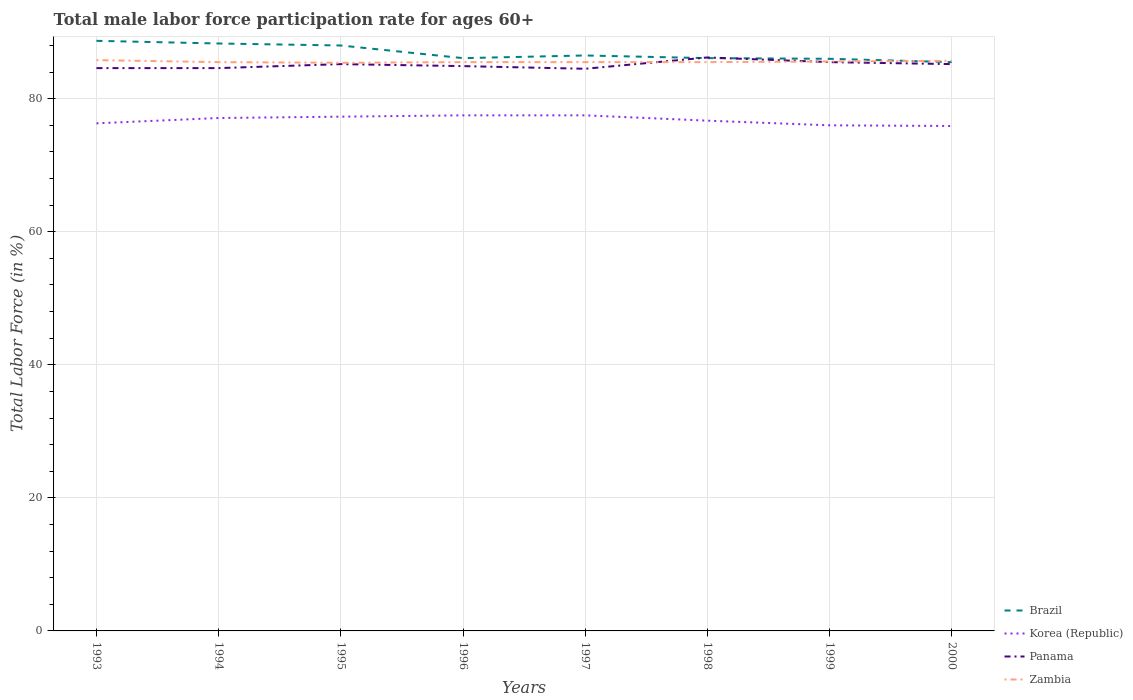How many different coloured lines are there?
Offer a very short reply. 4. Is the number of lines equal to the number of legend labels?
Offer a very short reply. Yes. Across all years, what is the maximum male labor force participation rate in Panama?
Offer a terse response. 84.5. What is the total male labor force participation rate in Panama in the graph?
Offer a terse response. 0.3. What is the difference between the highest and the second highest male labor force participation rate in Korea (Republic)?
Make the answer very short. 1.6. What is the difference between the highest and the lowest male labor force participation rate in Panama?
Give a very brief answer. 4. How many lines are there?
Provide a succinct answer. 4. What is the difference between two consecutive major ticks on the Y-axis?
Provide a succinct answer. 20. Does the graph contain any zero values?
Your answer should be compact. No. Where does the legend appear in the graph?
Provide a succinct answer. Bottom right. What is the title of the graph?
Your answer should be very brief. Total male labor force participation rate for ages 60+. Does "Hungary" appear as one of the legend labels in the graph?
Provide a succinct answer. No. What is the label or title of the X-axis?
Offer a very short reply. Years. What is the label or title of the Y-axis?
Make the answer very short. Total Labor Force (in %). What is the Total Labor Force (in %) of Brazil in 1993?
Ensure brevity in your answer.  88.7. What is the Total Labor Force (in %) in Korea (Republic) in 1993?
Give a very brief answer. 76.3. What is the Total Labor Force (in %) in Panama in 1993?
Offer a very short reply. 84.6. What is the Total Labor Force (in %) in Zambia in 1993?
Make the answer very short. 85.8. What is the Total Labor Force (in %) in Brazil in 1994?
Offer a very short reply. 88.3. What is the Total Labor Force (in %) in Korea (Republic) in 1994?
Your answer should be very brief. 77.1. What is the Total Labor Force (in %) of Panama in 1994?
Offer a terse response. 84.6. What is the Total Labor Force (in %) in Zambia in 1994?
Provide a succinct answer. 85.5. What is the Total Labor Force (in %) in Korea (Republic) in 1995?
Your answer should be very brief. 77.3. What is the Total Labor Force (in %) of Panama in 1995?
Keep it short and to the point. 85.2. What is the Total Labor Force (in %) in Zambia in 1995?
Provide a short and direct response. 85.4. What is the Total Labor Force (in %) in Brazil in 1996?
Offer a very short reply. 86.1. What is the Total Labor Force (in %) of Korea (Republic) in 1996?
Offer a terse response. 77.5. What is the Total Labor Force (in %) of Panama in 1996?
Provide a short and direct response. 84.9. What is the Total Labor Force (in %) in Zambia in 1996?
Your answer should be very brief. 85.5. What is the Total Labor Force (in %) in Brazil in 1997?
Your answer should be compact. 86.5. What is the Total Labor Force (in %) in Korea (Republic) in 1997?
Give a very brief answer. 77.5. What is the Total Labor Force (in %) in Panama in 1997?
Offer a very short reply. 84.5. What is the Total Labor Force (in %) of Zambia in 1997?
Your answer should be compact. 85.5. What is the Total Labor Force (in %) of Brazil in 1998?
Offer a very short reply. 86.1. What is the Total Labor Force (in %) in Korea (Republic) in 1998?
Offer a terse response. 76.7. What is the Total Labor Force (in %) in Panama in 1998?
Your answer should be compact. 86.2. What is the Total Labor Force (in %) of Zambia in 1998?
Offer a terse response. 85.5. What is the Total Labor Force (in %) in Brazil in 1999?
Your response must be concise. 86. What is the Total Labor Force (in %) of Panama in 1999?
Keep it short and to the point. 85.5. What is the Total Labor Force (in %) in Zambia in 1999?
Make the answer very short. 85.6. What is the Total Labor Force (in %) in Brazil in 2000?
Your answer should be compact. 85.5. What is the Total Labor Force (in %) of Korea (Republic) in 2000?
Keep it short and to the point. 75.9. What is the Total Labor Force (in %) in Panama in 2000?
Give a very brief answer. 85.2. What is the Total Labor Force (in %) of Zambia in 2000?
Provide a short and direct response. 85.7. Across all years, what is the maximum Total Labor Force (in %) in Brazil?
Make the answer very short. 88.7. Across all years, what is the maximum Total Labor Force (in %) of Korea (Republic)?
Your answer should be compact. 77.5. Across all years, what is the maximum Total Labor Force (in %) in Panama?
Offer a terse response. 86.2. Across all years, what is the maximum Total Labor Force (in %) in Zambia?
Provide a succinct answer. 85.8. Across all years, what is the minimum Total Labor Force (in %) in Brazil?
Give a very brief answer. 85.5. Across all years, what is the minimum Total Labor Force (in %) of Korea (Republic)?
Make the answer very short. 75.9. Across all years, what is the minimum Total Labor Force (in %) of Panama?
Your response must be concise. 84.5. Across all years, what is the minimum Total Labor Force (in %) in Zambia?
Provide a short and direct response. 85.4. What is the total Total Labor Force (in %) of Brazil in the graph?
Keep it short and to the point. 695.2. What is the total Total Labor Force (in %) of Korea (Republic) in the graph?
Give a very brief answer. 614.3. What is the total Total Labor Force (in %) in Panama in the graph?
Give a very brief answer. 680.7. What is the total Total Labor Force (in %) in Zambia in the graph?
Give a very brief answer. 684.5. What is the difference between the Total Labor Force (in %) of Brazil in 1993 and that in 1994?
Keep it short and to the point. 0.4. What is the difference between the Total Labor Force (in %) of Korea (Republic) in 1993 and that in 1994?
Your answer should be very brief. -0.8. What is the difference between the Total Labor Force (in %) of Panama in 1993 and that in 1994?
Your answer should be compact. 0. What is the difference between the Total Labor Force (in %) of Zambia in 1993 and that in 1994?
Keep it short and to the point. 0.3. What is the difference between the Total Labor Force (in %) in Brazil in 1993 and that in 1995?
Your response must be concise. 0.7. What is the difference between the Total Labor Force (in %) of Korea (Republic) in 1993 and that in 1995?
Ensure brevity in your answer.  -1. What is the difference between the Total Labor Force (in %) of Panama in 1993 and that in 1995?
Offer a terse response. -0.6. What is the difference between the Total Labor Force (in %) in Brazil in 1993 and that in 1996?
Your response must be concise. 2.6. What is the difference between the Total Labor Force (in %) in Korea (Republic) in 1993 and that in 1996?
Keep it short and to the point. -1.2. What is the difference between the Total Labor Force (in %) in Zambia in 1993 and that in 1996?
Offer a very short reply. 0.3. What is the difference between the Total Labor Force (in %) of Brazil in 1993 and that in 1997?
Provide a succinct answer. 2.2. What is the difference between the Total Labor Force (in %) of Korea (Republic) in 1993 and that in 1997?
Ensure brevity in your answer.  -1.2. What is the difference between the Total Labor Force (in %) of Panama in 1993 and that in 1998?
Ensure brevity in your answer.  -1.6. What is the difference between the Total Labor Force (in %) of Brazil in 1993 and that in 1999?
Keep it short and to the point. 2.7. What is the difference between the Total Labor Force (in %) of Korea (Republic) in 1993 and that in 1999?
Offer a terse response. 0.3. What is the difference between the Total Labor Force (in %) in Panama in 1993 and that in 1999?
Keep it short and to the point. -0.9. What is the difference between the Total Labor Force (in %) of Zambia in 1993 and that in 1999?
Provide a short and direct response. 0.2. What is the difference between the Total Labor Force (in %) of Korea (Republic) in 1993 and that in 2000?
Provide a succinct answer. 0.4. What is the difference between the Total Labor Force (in %) in Panama in 1993 and that in 2000?
Offer a very short reply. -0.6. What is the difference between the Total Labor Force (in %) of Zambia in 1993 and that in 2000?
Offer a very short reply. 0.1. What is the difference between the Total Labor Force (in %) of Brazil in 1994 and that in 1995?
Give a very brief answer. 0.3. What is the difference between the Total Labor Force (in %) of Panama in 1994 and that in 1995?
Provide a succinct answer. -0.6. What is the difference between the Total Labor Force (in %) in Brazil in 1994 and that in 1996?
Provide a short and direct response. 2.2. What is the difference between the Total Labor Force (in %) of Zambia in 1994 and that in 1996?
Offer a terse response. 0. What is the difference between the Total Labor Force (in %) in Brazil in 1994 and that in 1997?
Give a very brief answer. 1.8. What is the difference between the Total Labor Force (in %) in Panama in 1994 and that in 1997?
Offer a very short reply. 0.1. What is the difference between the Total Labor Force (in %) of Zambia in 1994 and that in 1997?
Keep it short and to the point. 0. What is the difference between the Total Labor Force (in %) in Brazil in 1994 and that in 1998?
Ensure brevity in your answer.  2.2. What is the difference between the Total Labor Force (in %) of Korea (Republic) in 1994 and that in 1998?
Make the answer very short. 0.4. What is the difference between the Total Labor Force (in %) in Brazil in 1994 and that in 1999?
Make the answer very short. 2.3. What is the difference between the Total Labor Force (in %) of Korea (Republic) in 1994 and that in 1999?
Keep it short and to the point. 1.1. What is the difference between the Total Labor Force (in %) of Zambia in 1994 and that in 1999?
Provide a short and direct response. -0.1. What is the difference between the Total Labor Force (in %) in Brazil in 1994 and that in 2000?
Give a very brief answer. 2.8. What is the difference between the Total Labor Force (in %) of Panama in 1994 and that in 2000?
Your answer should be compact. -0.6. What is the difference between the Total Labor Force (in %) of Panama in 1995 and that in 1996?
Give a very brief answer. 0.3. What is the difference between the Total Labor Force (in %) of Zambia in 1995 and that in 1996?
Keep it short and to the point. -0.1. What is the difference between the Total Labor Force (in %) in Brazil in 1995 and that in 1997?
Keep it short and to the point. 1.5. What is the difference between the Total Labor Force (in %) of Korea (Republic) in 1995 and that in 1997?
Make the answer very short. -0.2. What is the difference between the Total Labor Force (in %) of Panama in 1995 and that in 1997?
Ensure brevity in your answer.  0.7. What is the difference between the Total Labor Force (in %) of Korea (Republic) in 1995 and that in 1998?
Your answer should be compact. 0.6. What is the difference between the Total Labor Force (in %) in Panama in 1995 and that in 1998?
Make the answer very short. -1. What is the difference between the Total Labor Force (in %) in Zambia in 1995 and that in 1998?
Provide a short and direct response. -0.1. What is the difference between the Total Labor Force (in %) in Brazil in 1995 and that in 1999?
Your answer should be compact. 2. What is the difference between the Total Labor Force (in %) in Korea (Republic) in 1995 and that in 1999?
Keep it short and to the point. 1.3. What is the difference between the Total Labor Force (in %) of Brazil in 1995 and that in 2000?
Your answer should be compact. 2.5. What is the difference between the Total Labor Force (in %) in Korea (Republic) in 1995 and that in 2000?
Your answer should be compact. 1.4. What is the difference between the Total Labor Force (in %) in Panama in 1995 and that in 2000?
Your answer should be compact. 0. What is the difference between the Total Labor Force (in %) of Brazil in 1996 and that in 1997?
Give a very brief answer. -0.4. What is the difference between the Total Labor Force (in %) of Zambia in 1996 and that in 1997?
Offer a terse response. 0. What is the difference between the Total Labor Force (in %) in Brazil in 1996 and that in 1998?
Provide a succinct answer. 0. What is the difference between the Total Labor Force (in %) of Zambia in 1996 and that in 1998?
Offer a terse response. 0. What is the difference between the Total Labor Force (in %) of Brazil in 1996 and that in 1999?
Offer a very short reply. 0.1. What is the difference between the Total Labor Force (in %) in Brazil in 1996 and that in 2000?
Offer a terse response. 0.6. What is the difference between the Total Labor Force (in %) of Korea (Republic) in 1996 and that in 2000?
Ensure brevity in your answer.  1.6. What is the difference between the Total Labor Force (in %) of Zambia in 1996 and that in 2000?
Offer a terse response. -0.2. What is the difference between the Total Labor Force (in %) of Brazil in 1997 and that in 1998?
Your response must be concise. 0.4. What is the difference between the Total Labor Force (in %) of Zambia in 1997 and that in 1998?
Ensure brevity in your answer.  0. What is the difference between the Total Labor Force (in %) in Brazil in 1997 and that in 1999?
Give a very brief answer. 0.5. What is the difference between the Total Labor Force (in %) of Korea (Republic) in 1997 and that in 1999?
Offer a very short reply. 1.5. What is the difference between the Total Labor Force (in %) of Korea (Republic) in 1997 and that in 2000?
Keep it short and to the point. 1.6. What is the difference between the Total Labor Force (in %) in Zambia in 1997 and that in 2000?
Ensure brevity in your answer.  -0.2. What is the difference between the Total Labor Force (in %) in Zambia in 1998 and that in 1999?
Provide a succinct answer. -0.1. What is the difference between the Total Labor Force (in %) in Brazil in 1998 and that in 2000?
Your answer should be compact. 0.6. What is the difference between the Total Labor Force (in %) in Panama in 1998 and that in 2000?
Offer a very short reply. 1. What is the difference between the Total Labor Force (in %) in Zambia in 1998 and that in 2000?
Your answer should be very brief. -0.2. What is the difference between the Total Labor Force (in %) of Brazil in 1999 and that in 2000?
Make the answer very short. 0.5. What is the difference between the Total Labor Force (in %) of Korea (Republic) in 1999 and that in 2000?
Offer a terse response. 0.1. What is the difference between the Total Labor Force (in %) of Panama in 1999 and that in 2000?
Give a very brief answer. 0.3. What is the difference between the Total Labor Force (in %) of Zambia in 1999 and that in 2000?
Offer a terse response. -0.1. What is the difference between the Total Labor Force (in %) in Brazil in 1993 and the Total Labor Force (in %) in Korea (Republic) in 1994?
Keep it short and to the point. 11.6. What is the difference between the Total Labor Force (in %) in Brazil in 1993 and the Total Labor Force (in %) in Zambia in 1994?
Give a very brief answer. 3.2. What is the difference between the Total Labor Force (in %) in Brazil in 1993 and the Total Labor Force (in %) in Panama in 1995?
Offer a very short reply. 3.5. What is the difference between the Total Labor Force (in %) in Brazil in 1993 and the Total Labor Force (in %) in Korea (Republic) in 1996?
Your answer should be very brief. 11.2. What is the difference between the Total Labor Force (in %) in Brazil in 1993 and the Total Labor Force (in %) in Zambia in 1996?
Provide a short and direct response. 3.2. What is the difference between the Total Labor Force (in %) in Brazil in 1993 and the Total Labor Force (in %) in Korea (Republic) in 1997?
Provide a succinct answer. 11.2. What is the difference between the Total Labor Force (in %) of Brazil in 1993 and the Total Labor Force (in %) of Zambia in 1997?
Offer a terse response. 3.2. What is the difference between the Total Labor Force (in %) of Korea (Republic) in 1993 and the Total Labor Force (in %) of Panama in 1997?
Provide a succinct answer. -8.2. What is the difference between the Total Labor Force (in %) of Korea (Republic) in 1993 and the Total Labor Force (in %) of Zambia in 1997?
Your answer should be very brief. -9.2. What is the difference between the Total Labor Force (in %) in Panama in 1993 and the Total Labor Force (in %) in Zambia in 1997?
Your response must be concise. -0.9. What is the difference between the Total Labor Force (in %) in Korea (Republic) in 1993 and the Total Labor Force (in %) in Panama in 1998?
Your answer should be very brief. -9.9. What is the difference between the Total Labor Force (in %) in Brazil in 1993 and the Total Labor Force (in %) in Zambia in 1999?
Keep it short and to the point. 3.1. What is the difference between the Total Labor Force (in %) of Korea (Republic) in 1993 and the Total Labor Force (in %) of Panama in 1999?
Keep it short and to the point. -9.2. What is the difference between the Total Labor Force (in %) in Brazil in 1993 and the Total Labor Force (in %) in Panama in 2000?
Offer a terse response. 3.5. What is the difference between the Total Labor Force (in %) of Brazil in 1993 and the Total Labor Force (in %) of Zambia in 2000?
Provide a short and direct response. 3. What is the difference between the Total Labor Force (in %) in Korea (Republic) in 1993 and the Total Labor Force (in %) in Panama in 2000?
Offer a terse response. -8.9. What is the difference between the Total Labor Force (in %) in Panama in 1993 and the Total Labor Force (in %) in Zambia in 2000?
Your response must be concise. -1.1. What is the difference between the Total Labor Force (in %) of Brazil in 1994 and the Total Labor Force (in %) of Korea (Republic) in 1995?
Provide a short and direct response. 11. What is the difference between the Total Labor Force (in %) of Brazil in 1994 and the Total Labor Force (in %) of Panama in 1995?
Your answer should be compact. 3.1. What is the difference between the Total Labor Force (in %) of Korea (Republic) in 1994 and the Total Labor Force (in %) of Panama in 1995?
Keep it short and to the point. -8.1. What is the difference between the Total Labor Force (in %) of Korea (Republic) in 1994 and the Total Labor Force (in %) of Zambia in 1995?
Keep it short and to the point. -8.3. What is the difference between the Total Labor Force (in %) in Brazil in 1994 and the Total Labor Force (in %) in Korea (Republic) in 1996?
Your answer should be very brief. 10.8. What is the difference between the Total Labor Force (in %) in Korea (Republic) in 1994 and the Total Labor Force (in %) in Panama in 1996?
Your response must be concise. -7.8. What is the difference between the Total Labor Force (in %) of Brazil in 1994 and the Total Labor Force (in %) of Panama in 1997?
Offer a very short reply. 3.8. What is the difference between the Total Labor Force (in %) in Korea (Republic) in 1994 and the Total Labor Force (in %) in Zambia in 1997?
Offer a terse response. -8.4. What is the difference between the Total Labor Force (in %) of Brazil in 1994 and the Total Labor Force (in %) of Korea (Republic) in 1998?
Ensure brevity in your answer.  11.6. What is the difference between the Total Labor Force (in %) in Brazil in 1994 and the Total Labor Force (in %) in Panama in 1998?
Offer a very short reply. 2.1. What is the difference between the Total Labor Force (in %) of Korea (Republic) in 1994 and the Total Labor Force (in %) of Zambia in 1998?
Ensure brevity in your answer.  -8.4. What is the difference between the Total Labor Force (in %) of Brazil in 1994 and the Total Labor Force (in %) of Zambia in 1999?
Keep it short and to the point. 2.7. What is the difference between the Total Labor Force (in %) in Panama in 1994 and the Total Labor Force (in %) in Zambia in 1999?
Your answer should be very brief. -1. What is the difference between the Total Labor Force (in %) of Brazil in 1994 and the Total Labor Force (in %) of Korea (Republic) in 2000?
Offer a very short reply. 12.4. What is the difference between the Total Labor Force (in %) of Brazil in 1994 and the Total Labor Force (in %) of Panama in 2000?
Ensure brevity in your answer.  3.1. What is the difference between the Total Labor Force (in %) in Korea (Republic) in 1995 and the Total Labor Force (in %) in Panama in 1996?
Give a very brief answer. -7.6. What is the difference between the Total Labor Force (in %) in Panama in 1995 and the Total Labor Force (in %) in Zambia in 1996?
Keep it short and to the point. -0.3. What is the difference between the Total Labor Force (in %) in Brazil in 1995 and the Total Labor Force (in %) in Korea (Republic) in 1997?
Your answer should be compact. 10.5. What is the difference between the Total Labor Force (in %) of Brazil in 1995 and the Total Labor Force (in %) of Panama in 1997?
Keep it short and to the point. 3.5. What is the difference between the Total Labor Force (in %) of Brazil in 1995 and the Total Labor Force (in %) of Zambia in 1997?
Provide a succinct answer. 2.5. What is the difference between the Total Labor Force (in %) of Korea (Republic) in 1995 and the Total Labor Force (in %) of Panama in 1997?
Provide a short and direct response. -7.2. What is the difference between the Total Labor Force (in %) in Brazil in 1995 and the Total Labor Force (in %) in Korea (Republic) in 1998?
Provide a succinct answer. 11.3. What is the difference between the Total Labor Force (in %) of Brazil in 1995 and the Total Labor Force (in %) of Zambia in 1998?
Ensure brevity in your answer.  2.5. What is the difference between the Total Labor Force (in %) in Korea (Republic) in 1995 and the Total Labor Force (in %) in Panama in 1998?
Provide a succinct answer. -8.9. What is the difference between the Total Labor Force (in %) of Panama in 1995 and the Total Labor Force (in %) of Zambia in 1998?
Your answer should be compact. -0.3. What is the difference between the Total Labor Force (in %) of Brazil in 1995 and the Total Labor Force (in %) of Korea (Republic) in 1999?
Provide a short and direct response. 12. What is the difference between the Total Labor Force (in %) in Brazil in 1995 and the Total Labor Force (in %) in Panama in 1999?
Provide a succinct answer. 2.5. What is the difference between the Total Labor Force (in %) in Brazil in 1995 and the Total Labor Force (in %) in Zambia in 1999?
Provide a short and direct response. 2.4. What is the difference between the Total Labor Force (in %) in Panama in 1995 and the Total Labor Force (in %) in Zambia in 1999?
Your answer should be compact. -0.4. What is the difference between the Total Labor Force (in %) in Brazil in 1995 and the Total Labor Force (in %) in Korea (Republic) in 2000?
Offer a very short reply. 12.1. What is the difference between the Total Labor Force (in %) of Korea (Republic) in 1995 and the Total Labor Force (in %) of Zambia in 2000?
Offer a very short reply. -8.4. What is the difference between the Total Labor Force (in %) in Panama in 1995 and the Total Labor Force (in %) in Zambia in 2000?
Your answer should be compact. -0.5. What is the difference between the Total Labor Force (in %) of Brazil in 1996 and the Total Labor Force (in %) of Panama in 1997?
Your answer should be compact. 1.6. What is the difference between the Total Labor Force (in %) in Brazil in 1996 and the Total Labor Force (in %) in Zambia in 1997?
Provide a succinct answer. 0.6. What is the difference between the Total Labor Force (in %) of Korea (Republic) in 1996 and the Total Labor Force (in %) of Panama in 1997?
Give a very brief answer. -7. What is the difference between the Total Labor Force (in %) of Korea (Republic) in 1996 and the Total Labor Force (in %) of Zambia in 1997?
Make the answer very short. -8. What is the difference between the Total Labor Force (in %) in Panama in 1996 and the Total Labor Force (in %) in Zambia in 1997?
Your response must be concise. -0.6. What is the difference between the Total Labor Force (in %) in Korea (Republic) in 1996 and the Total Labor Force (in %) in Zambia in 1998?
Your answer should be compact. -8. What is the difference between the Total Labor Force (in %) in Panama in 1996 and the Total Labor Force (in %) in Zambia in 1998?
Make the answer very short. -0.6. What is the difference between the Total Labor Force (in %) in Brazil in 1996 and the Total Labor Force (in %) in Korea (Republic) in 1999?
Your answer should be very brief. 10.1. What is the difference between the Total Labor Force (in %) of Brazil in 1996 and the Total Labor Force (in %) of Zambia in 1999?
Provide a short and direct response. 0.5. What is the difference between the Total Labor Force (in %) in Brazil in 1996 and the Total Labor Force (in %) in Zambia in 2000?
Give a very brief answer. 0.4. What is the difference between the Total Labor Force (in %) in Brazil in 1997 and the Total Labor Force (in %) in Korea (Republic) in 1998?
Your answer should be compact. 9.8. What is the difference between the Total Labor Force (in %) of Brazil in 1997 and the Total Labor Force (in %) of Panama in 1998?
Provide a short and direct response. 0.3. What is the difference between the Total Labor Force (in %) of Korea (Republic) in 1997 and the Total Labor Force (in %) of Zambia in 1998?
Your response must be concise. -8. What is the difference between the Total Labor Force (in %) of Panama in 1997 and the Total Labor Force (in %) of Zambia in 1998?
Keep it short and to the point. -1. What is the difference between the Total Labor Force (in %) in Brazil in 1997 and the Total Labor Force (in %) in Zambia in 1999?
Give a very brief answer. 0.9. What is the difference between the Total Labor Force (in %) in Brazil in 1997 and the Total Labor Force (in %) in Korea (Republic) in 2000?
Provide a short and direct response. 10.6. What is the difference between the Total Labor Force (in %) in Brazil in 1997 and the Total Labor Force (in %) in Panama in 2000?
Make the answer very short. 1.3. What is the difference between the Total Labor Force (in %) in Brazil in 1997 and the Total Labor Force (in %) in Zambia in 2000?
Ensure brevity in your answer.  0.8. What is the difference between the Total Labor Force (in %) of Brazil in 1998 and the Total Labor Force (in %) of Zambia in 1999?
Provide a short and direct response. 0.5. What is the difference between the Total Labor Force (in %) of Korea (Republic) in 1998 and the Total Labor Force (in %) of Panama in 1999?
Your answer should be very brief. -8.8. What is the difference between the Total Labor Force (in %) in Korea (Republic) in 1998 and the Total Labor Force (in %) in Zambia in 1999?
Keep it short and to the point. -8.9. What is the difference between the Total Labor Force (in %) of Korea (Republic) in 1998 and the Total Labor Force (in %) of Zambia in 2000?
Offer a terse response. -9. What is the difference between the Total Labor Force (in %) of Panama in 1998 and the Total Labor Force (in %) of Zambia in 2000?
Offer a terse response. 0.5. What is the difference between the Total Labor Force (in %) of Brazil in 1999 and the Total Labor Force (in %) of Zambia in 2000?
Offer a very short reply. 0.3. What is the difference between the Total Labor Force (in %) of Korea (Republic) in 1999 and the Total Labor Force (in %) of Panama in 2000?
Make the answer very short. -9.2. What is the difference between the Total Labor Force (in %) of Panama in 1999 and the Total Labor Force (in %) of Zambia in 2000?
Provide a short and direct response. -0.2. What is the average Total Labor Force (in %) in Brazil per year?
Your answer should be very brief. 86.9. What is the average Total Labor Force (in %) in Korea (Republic) per year?
Keep it short and to the point. 76.79. What is the average Total Labor Force (in %) of Panama per year?
Keep it short and to the point. 85.09. What is the average Total Labor Force (in %) of Zambia per year?
Ensure brevity in your answer.  85.56. In the year 1993, what is the difference between the Total Labor Force (in %) of Brazil and Total Labor Force (in %) of Korea (Republic)?
Provide a succinct answer. 12.4. In the year 1993, what is the difference between the Total Labor Force (in %) of Brazil and Total Labor Force (in %) of Panama?
Provide a succinct answer. 4.1. In the year 1993, what is the difference between the Total Labor Force (in %) in Brazil and Total Labor Force (in %) in Zambia?
Offer a very short reply. 2.9. In the year 1993, what is the difference between the Total Labor Force (in %) in Korea (Republic) and Total Labor Force (in %) in Panama?
Your answer should be compact. -8.3. In the year 1993, what is the difference between the Total Labor Force (in %) in Panama and Total Labor Force (in %) in Zambia?
Give a very brief answer. -1.2. In the year 1994, what is the difference between the Total Labor Force (in %) in Brazil and Total Labor Force (in %) in Korea (Republic)?
Offer a very short reply. 11.2. In the year 1994, what is the difference between the Total Labor Force (in %) of Brazil and Total Labor Force (in %) of Panama?
Keep it short and to the point. 3.7. In the year 1994, what is the difference between the Total Labor Force (in %) of Brazil and Total Labor Force (in %) of Zambia?
Your answer should be compact. 2.8. In the year 1994, what is the difference between the Total Labor Force (in %) in Korea (Republic) and Total Labor Force (in %) in Panama?
Your answer should be compact. -7.5. In the year 1995, what is the difference between the Total Labor Force (in %) of Brazil and Total Labor Force (in %) of Panama?
Offer a terse response. 2.8. In the year 1995, what is the difference between the Total Labor Force (in %) of Korea (Republic) and Total Labor Force (in %) of Panama?
Ensure brevity in your answer.  -7.9. In the year 1995, what is the difference between the Total Labor Force (in %) of Korea (Republic) and Total Labor Force (in %) of Zambia?
Keep it short and to the point. -8.1. In the year 1996, what is the difference between the Total Labor Force (in %) in Brazil and Total Labor Force (in %) in Zambia?
Give a very brief answer. 0.6. In the year 1996, what is the difference between the Total Labor Force (in %) of Korea (Republic) and Total Labor Force (in %) of Panama?
Make the answer very short. -7.4. In the year 1997, what is the difference between the Total Labor Force (in %) of Brazil and Total Labor Force (in %) of Panama?
Keep it short and to the point. 2. In the year 1997, what is the difference between the Total Labor Force (in %) of Brazil and Total Labor Force (in %) of Zambia?
Give a very brief answer. 1. In the year 1997, what is the difference between the Total Labor Force (in %) of Korea (Republic) and Total Labor Force (in %) of Panama?
Give a very brief answer. -7. In the year 1997, what is the difference between the Total Labor Force (in %) in Korea (Republic) and Total Labor Force (in %) in Zambia?
Your answer should be compact. -8. In the year 1998, what is the difference between the Total Labor Force (in %) of Brazil and Total Labor Force (in %) of Panama?
Make the answer very short. -0.1. In the year 1998, what is the difference between the Total Labor Force (in %) of Brazil and Total Labor Force (in %) of Zambia?
Provide a succinct answer. 0.6. In the year 1998, what is the difference between the Total Labor Force (in %) of Korea (Republic) and Total Labor Force (in %) of Panama?
Your response must be concise. -9.5. In the year 1998, what is the difference between the Total Labor Force (in %) in Panama and Total Labor Force (in %) in Zambia?
Give a very brief answer. 0.7. In the year 1999, what is the difference between the Total Labor Force (in %) in Korea (Republic) and Total Labor Force (in %) in Zambia?
Your response must be concise. -9.6. In the year 1999, what is the difference between the Total Labor Force (in %) in Panama and Total Labor Force (in %) in Zambia?
Offer a terse response. -0.1. In the year 2000, what is the difference between the Total Labor Force (in %) in Brazil and Total Labor Force (in %) in Korea (Republic)?
Give a very brief answer. 9.6. What is the ratio of the Total Labor Force (in %) of Brazil in 1993 to that in 1995?
Offer a very short reply. 1.01. What is the ratio of the Total Labor Force (in %) of Korea (Republic) in 1993 to that in 1995?
Offer a very short reply. 0.99. What is the ratio of the Total Labor Force (in %) in Zambia in 1993 to that in 1995?
Your answer should be compact. 1. What is the ratio of the Total Labor Force (in %) in Brazil in 1993 to that in 1996?
Your response must be concise. 1.03. What is the ratio of the Total Labor Force (in %) of Korea (Republic) in 1993 to that in 1996?
Keep it short and to the point. 0.98. What is the ratio of the Total Labor Force (in %) in Brazil in 1993 to that in 1997?
Provide a succinct answer. 1.03. What is the ratio of the Total Labor Force (in %) of Korea (Republic) in 1993 to that in 1997?
Offer a terse response. 0.98. What is the ratio of the Total Labor Force (in %) in Brazil in 1993 to that in 1998?
Make the answer very short. 1.03. What is the ratio of the Total Labor Force (in %) in Korea (Republic) in 1993 to that in 1998?
Your answer should be compact. 0.99. What is the ratio of the Total Labor Force (in %) of Panama in 1993 to that in 1998?
Offer a very short reply. 0.98. What is the ratio of the Total Labor Force (in %) in Zambia in 1993 to that in 1998?
Make the answer very short. 1. What is the ratio of the Total Labor Force (in %) of Brazil in 1993 to that in 1999?
Offer a very short reply. 1.03. What is the ratio of the Total Labor Force (in %) of Korea (Republic) in 1993 to that in 1999?
Keep it short and to the point. 1. What is the ratio of the Total Labor Force (in %) in Panama in 1993 to that in 1999?
Keep it short and to the point. 0.99. What is the ratio of the Total Labor Force (in %) in Zambia in 1993 to that in 1999?
Your answer should be very brief. 1. What is the ratio of the Total Labor Force (in %) in Brazil in 1993 to that in 2000?
Provide a short and direct response. 1.04. What is the ratio of the Total Labor Force (in %) in Korea (Republic) in 1993 to that in 2000?
Provide a succinct answer. 1.01. What is the ratio of the Total Labor Force (in %) in Zambia in 1993 to that in 2000?
Give a very brief answer. 1. What is the ratio of the Total Labor Force (in %) of Brazil in 1994 to that in 1995?
Make the answer very short. 1. What is the ratio of the Total Labor Force (in %) of Korea (Republic) in 1994 to that in 1995?
Keep it short and to the point. 1. What is the ratio of the Total Labor Force (in %) in Brazil in 1994 to that in 1996?
Your answer should be compact. 1.03. What is the ratio of the Total Labor Force (in %) of Zambia in 1994 to that in 1996?
Ensure brevity in your answer.  1. What is the ratio of the Total Labor Force (in %) of Brazil in 1994 to that in 1997?
Keep it short and to the point. 1.02. What is the ratio of the Total Labor Force (in %) of Korea (Republic) in 1994 to that in 1997?
Your response must be concise. 0.99. What is the ratio of the Total Labor Force (in %) in Zambia in 1994 to that in 1997?
Ensure brevity in your answer.  1. What is the ratio of the Total Labor Force (in %) of Brazil in 1994 to that in 1998?
Provide a short and direct response. 1.03. What is the ratio of the Total Labor Force (in %) in Panama in 1994 to that in 1998?
Provide a succinct answer. 0.98. What is the ratio of the Total Labor Force (in %) of Brazil in 1994 to that in 1999?
Give a very brief answer. 1.03. What is the ratio of the Total Labor Force (in %) of Korea (Republic) in 1994 to that in 1999?
Your answer should be very brief. 1.01. What is the ratio of the Total Labor Force (in %) of Zambia in 1994 to that in 1999?
Offer a very short reply. 1. What is the ratio of the Total Labor Force (in %) of Brazil in 1994 to that in 2000?
Provide a succinct answer. 1.03. What is the ratio of the Total Labor Force (in %) of Korea (Republic) in 1994 to that in 2000?
Offer a terse response. 1.02. What is the ratio of the Total Labor Force (in %) of Panama in 1994 to that in 2000?
Give a very brief answer. 0.99. What is the ratio of the Total Labor Force (in %) in Brazil in 1995 to that in 1996?
Offer a very short reply. 1.02. What is the ratio of the Total Labor Force (in %) in Zambia in 1995 to that in 1996?
Your response must be concise. 1. What is the ratio of the Total Labor Force (in %) of Brazil in 1995 to that in 1997?
Ensure brevity in your answer.  1.02. What is the ratio of the Total Labor Force (in %) of Panama in 1995 to that in 1997?
Provide a short and direct response. 1.01. What is the ratio of the Total Labor Force (in %) of Zambia in 1995 to that in 1997?
Ensure brevity in your answer.  1. What is the ratio of the Total Labor Force (in %) of Brazil in 1995 to that in 1998?
Provide a short and direct response. 1.02. What is the ratio of the Total Labor Force (in %) in Korea (Republic) in 1995 to that in 1998?
Your answer should be compact. 1.01. What is the ratio of the Total Labor Force (in %) in Panama in 1995 to that in 1998?
Offer a very short reply. 0.99. What is the ratio of the Total Labor Force (in %) of Zambia in 1995 to that in 1998?
Keep it short and to the point. 1. What is the ratio of the Total Labor Force (in %) of Brazil in 1995 to that in 1999?
Provide a short and direct response. 1.02. What is the ratio of the Total Labor Force (in %) of Korea (Republic) in 1995 to that in 1999?
Provide a succinct answer. 1.02. What is the ratio of the Total Labor Force (in %) of Brazil in 1995 to that in 2000?
Provide a short and direct response. 1.03. What is the ratio of the Total Labor Force (in %) in Korea (Republic) in 1995 to that in 2000?
Keep it short and to the point. 1.02. What is the ratio of the Total Labor Force (in %) of Zambia in 1995 to that in 2000?
Make the answer very short. 1. What is the ratio of the Total Labor Force (in %) of Korea (Republic) in 1996 to that in 1997?
Keep it short and to the point. 1. What is the ratio of the Total Labor Force (in %) of Panama in 1996 to that in 1997?
Give a very brief answer. 1. What is the ratio of the Total Labor Force (in %) in Zambia in 1996 to that in 1997?
Ensure brevity in your answer.  1. What is the ratio of the Total Labor Force (in %) in Korea (Republic) in 1996 to that in 1998?
Offer a very short reply. 1.01. What is the ratio of the Total Labor Force (in %) of Panama in 1996 to that in 1998?
Your answer should be very brief. 0.98. What is the ratio of the Total Labor Force (in %) of Zambia in 1996 to that in 1998?
Your answer should be compact. 1. What is the ratio of the Total Labor Force (in %) in Brazil in 1996 to that in 1999?
Your answer should be compact. 1. What is the ratio of the Total Labor Force (in %) in Korea (Republic) in 1996 to that in 1999?
Your response must be concise. 1.02. What is the ratio of the Total Labor Force (in %) in Panama in 1996 to that in 1999?
Keep it short and to the point. 0.99. What is the ratio of the Total Labor Force (in %) in Brazil in 1996 to that in 2000?
Provide a succinct answer. 1.01. What is the ratio of the Total Labor Force (in %) in Korea (Republic) in 1996 to that in 2000?
Your response must be concise. 1.02. What is the ratio of the Total Labor Force (in %) of Panama in 1996 to that in 2000?
Keep it short and to the point. 1. What is the ratio of the Total Labor Force (in %) of Korea (Republic) in 1997 to that in 1998?
Your response must be concise. 1.01. What is the ratio of the Total Labor Force (in %) in Panama in 1997 to that in 1998?
Your response must be concise. 0.98. What is the ratio of the Total Labor Force (in %) in Korea (Republic) in 1997 to that in 1999?
Make the answer very short. 1.02. What is the ratio of the Total Labor Force (in %) of Panama in 1997 to that in 1999?
Ensure brevity in your answer.  0.99. What is the ratio of the Total Labor Force (in %) in Zambia in 1997 to that in 1999?
Keep it short and to the point. 1. What is the ratio of the Total Labor Force (in %) of Brazil in 1997 to that in 2000?
Offer a terse response. 1.01. What is the ratio of the Total Labor Force (in %) of Korea (Republic) in 1997 to that in 2000?
Offer a very short reply. 1.02. What is the ratio of the Total Labor Force (in %) in Panama in 1997 to that in 2000?
Provide a short and direct response. 0.99. What is the ratio of the Total Labor Force (in %) in Korea (Republic) in 1998 to that in 1999?
Your answer should be very brief. 1.01. What is the ratio of the Total Labor Force (in %) of Panama in 1998 to that in 1999?
Ensure brevity in your answer.  1.01. What is the ratio of the Total Labor Force (in %) of Zambia in 1998 to that in 1999?
Keep it short and to the point. 1. What is the ratio of the Total Labor Force (in %) in Korea (Republic) in 1998 to that in 2000?
Make the answer very short. 1.01. What is the ratio of the Total Labor Force (in %) in Panama in 1998 to that in 2000?
Provide a succinct answer. 1.01. What is the ratio of the Total Labor Force (in %) of Korea (Republic) in 1999 to that in 2000?
Your answer should be compact. 1. What is the ratio of the Total Labor Force (in %) in Panama in 1999 to that in 2000?
Your answer should be very brief. 1. What is the ratio of the Total Labor Force (in %) of Zambia in 1999 to that in 2000?
Give a very brief answer. 1. What is the difference between the highest and the second highest Total Labor Force (in %) in Brazil?
Make the answer very short. 0.4. What is the difference between the highest and the second highest Total Labor Force (in %) in Korea (Republic)?
Offer a very short reply. 0. What is the difference between the highest and the second highest Total Labor Force (in %) of Zambia?
Give a very brief answer. 0.1. What is the difference between the highest and the lowest Total Labor Force (in %) of Panama?
Your response must be concise. 1.7. What is the difference between the highest and the lowest Total Labor Force (in %) in Zambia?
Provide a short and direct response. 0.4. 